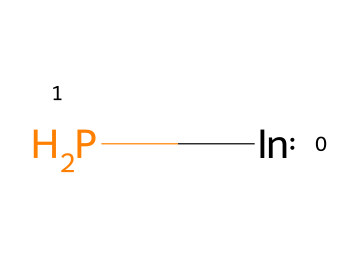What is the name of this chemical? The SMILES notation [In]P represents indium phosphide, which consists of indium (In) and phosphorus (P). Therefore, the name of the chemical is derived directly from the elements present in the structure.
Answer: indium phosphide How many atoms are in the chemical structure? In the chemical structure represented by the SMILES notation, there are two distinct atoms: one indium atom and one phosphorus atom. Thus, adding them gives a total of two atoms in the molecule.
Answer: two What type of bonding is present in indium phosphide? Indium phosphide (InP) is typically described as having covalent bonding between the indium and phosphorus atoms, which is typical for compounds involving nonmetals and metalloids. Covalent bonds are formed when electrons are shared between atoms.
Answer: covalent What is the primary application of indium phosphide in technology? Indium phosphide is commonly used in the fabrication of quantum dots and optoelectronic devices like lasers and photodetectors. Its unique electronic properties make it suitable for applications in high-speed electronics and holographic projection systems.
Answer: holographic projection What property of indium phosphide makes it suitable for quantum dot applications? The semiconductor properties of indium phosphide allow for the efficient size-tunable photoluminescence, which is crucial for the performance of quantum dots in various applications, including imaging and projection technologies.
Answer: photoluminescence Which element in indium phosphide contributes to its electronic properties? Indium contributes to the electronic properties of indium phosphide as it is a key component of the semiconductor material, influencing the bandgap and charge carrier mobility, both of which are critical for its functionalities.
Answer: indium 